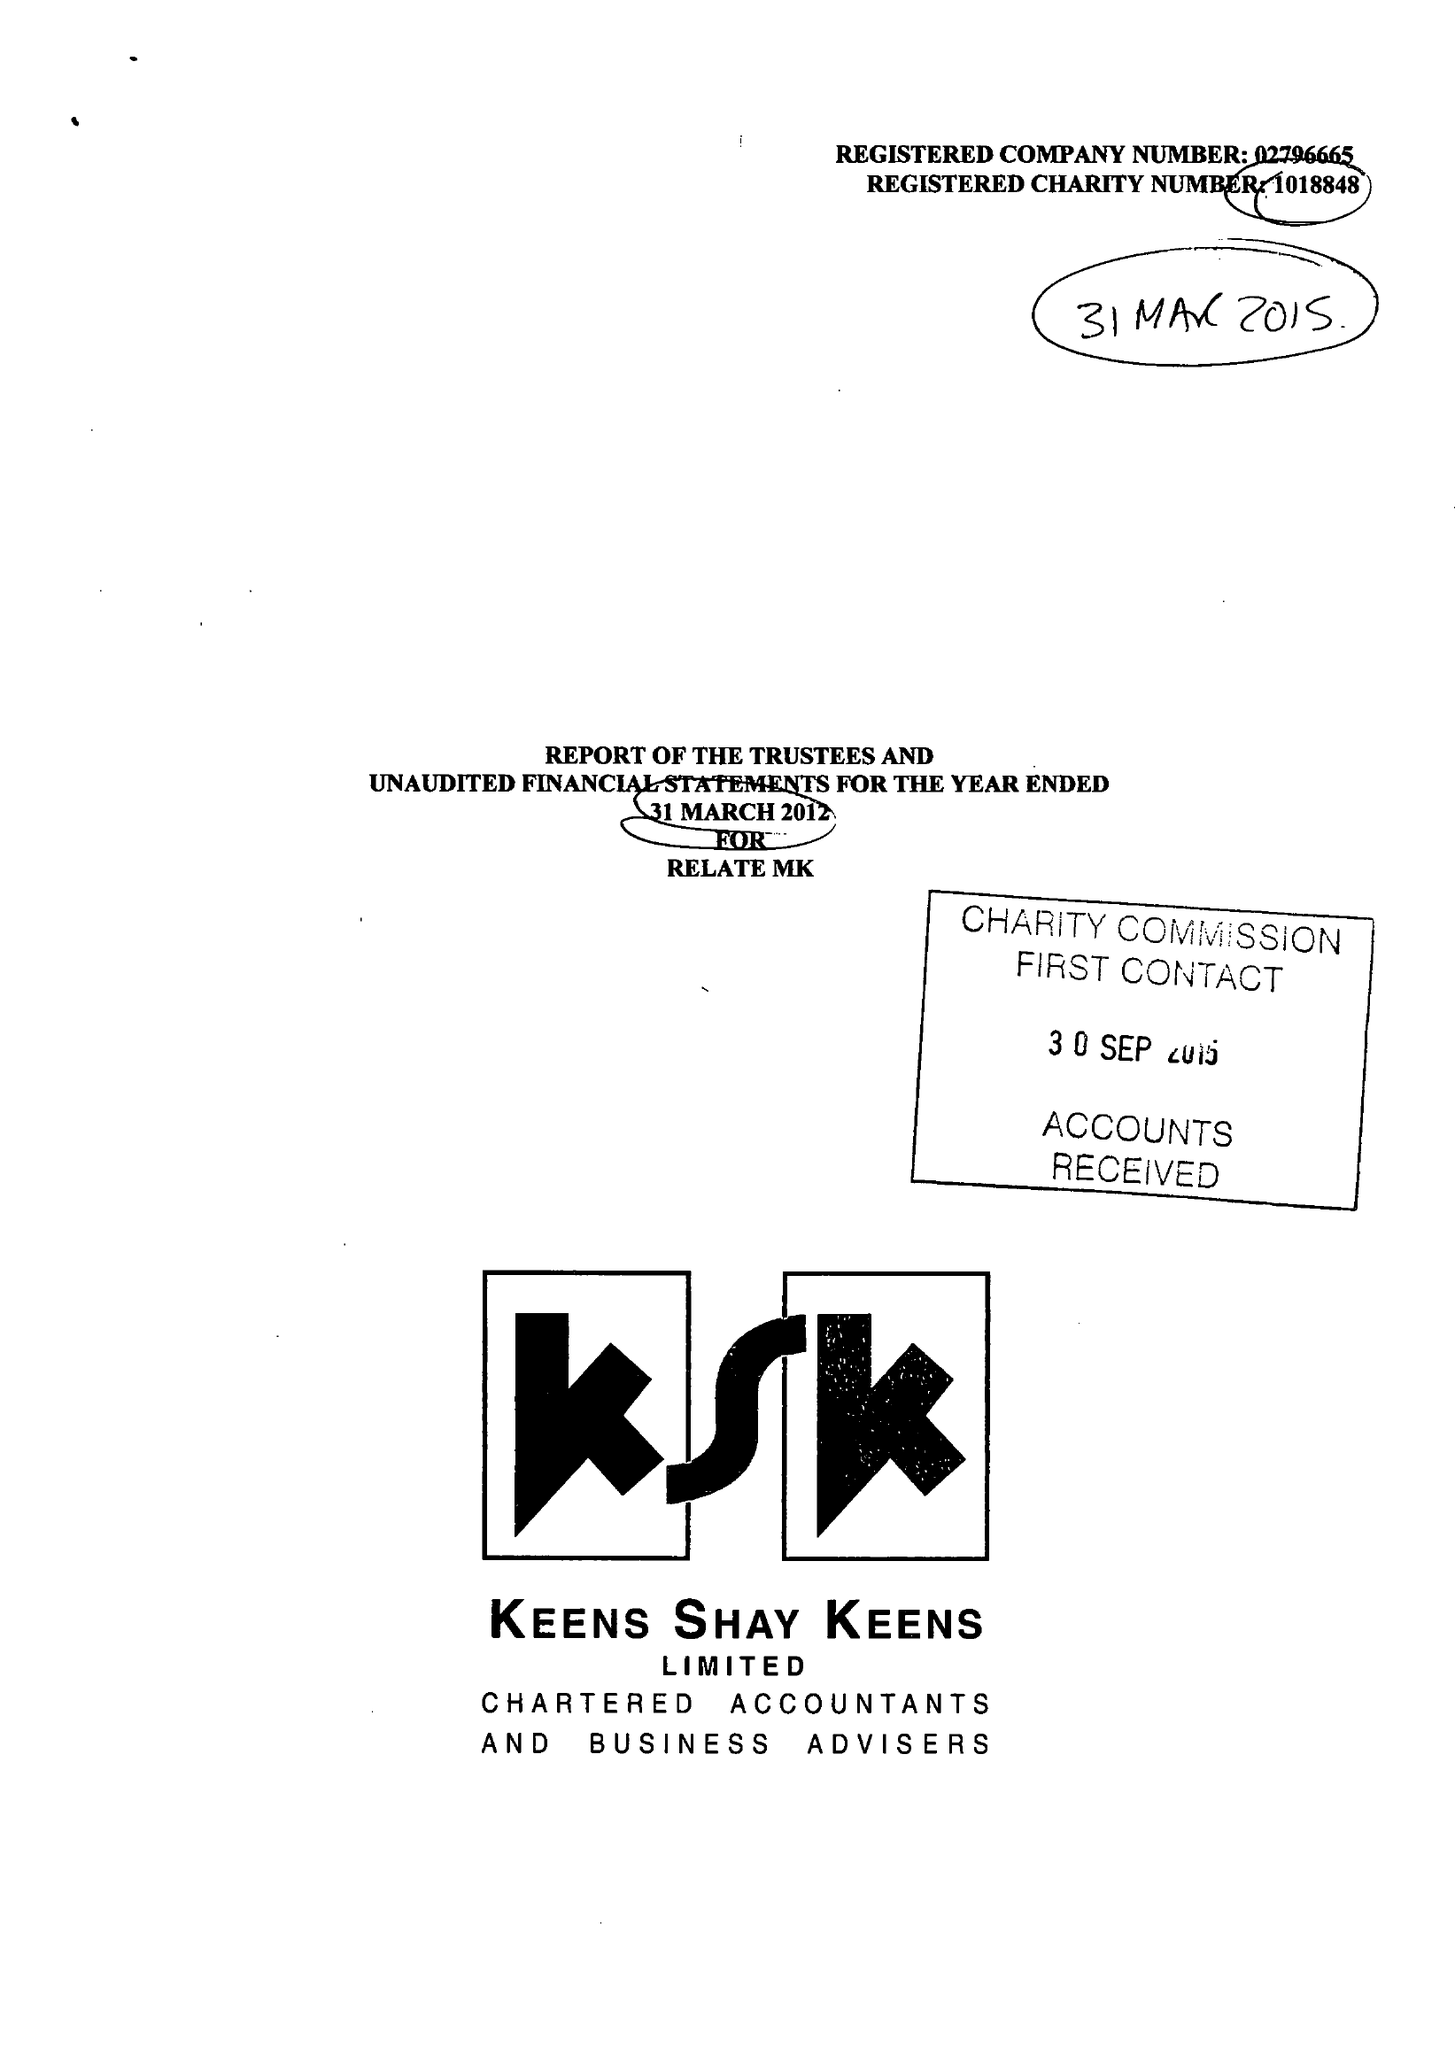What is the value for the income_annually_in_british_pounds?
Answer the question using a single word or phrase. 230310.00 